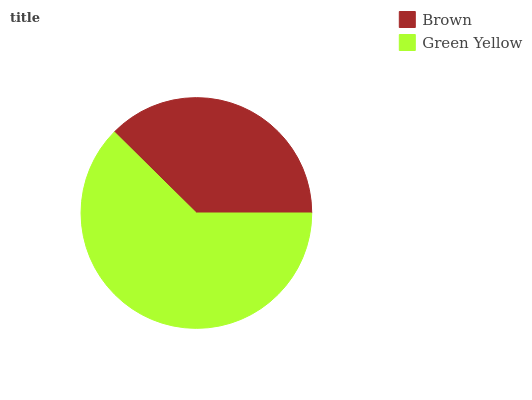Is Brown the minimum?
Answer yes or no. Yes. Is Green Yellow the maximum?
Answer yes or no. Yes. Is Green Yellow the minimum?
Answer yes or no. No. Is Green Yellow greater than Brown?
Answer yes or no. Yes. Is Brown less than Green Yellow?
Answer yes or no. Yes. Is Brown greater than Green Yellow?
Answer yes or no. No. Is Green Yellow less than Brown?
Answer yes or no. No. Is Green Yellow the high median?
Answer yes or no. Yes. Is Brown the low median?
Answer yes or no. Yes. Is Brown the high median?
Answer yes or no. No. Is Green Yellow the low median?
Answer yes or no. No. 